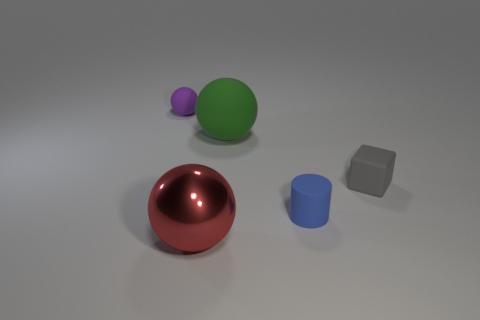Subtract all small rubber balls. How many balls are left? 2 Add 5 big yellow shiny cylinders. How many objects exist? 10 Subtract all cylinders. How many objects are left? 4 Subtract all gray spheres. Subtract all red blocks. How many spheres are left? 3 Subtract all matte cylinders. Subtract all rubber blocks. How many objects are left? 3 Add 5 tiny matte cylinders. How many tiny matte cylinders are left? 6 Add 1 large metal balls. How many large metal balls exist? 2 Subtract 0 brown cylinders. How many objects are left? 5 